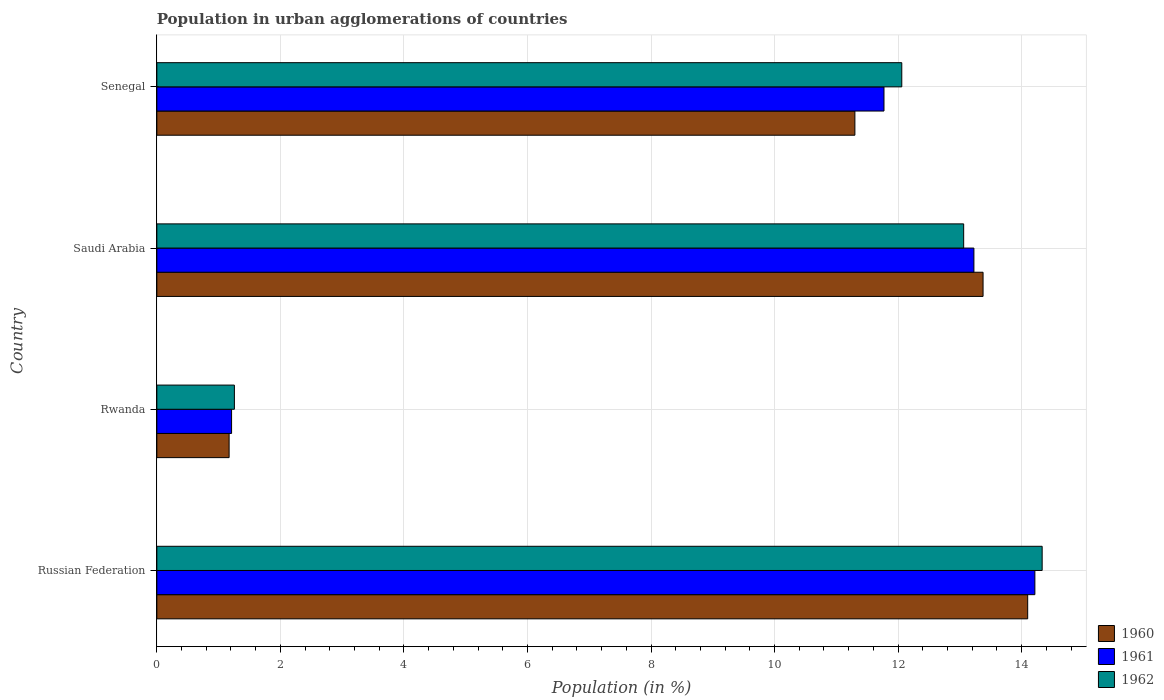How many bars are there on the 4th tick from the top?
Provide a succinct answer. 3. What is the label of the 2nd group of bars from the top?
Offer a very short reply. Saudi Arabia. What is the percentage of population in urban agglomerations in 1962 in Russian Federation?
Keep it short and to the point. 14.33. Across all countries, what is the maximum percentage of population in urban agglomerations in 1960?
Offer a very short reply. 14.1. Across all countries, what is the minimum percentage of population in urban agglomerations in 1962?
Offer a terse response. 1.26. In which country was the percentage of population in urban agglomerations in 1960 maximum?
Ensure brevity in your answer.  Russian Federation. In which country was the percentage of population in urban agglomerations in 1960 minimum?
Make the answer very short. Rwanda. What is the total percentage of population in urban agglomerations in 1962 in the graph?
Your answer should be very brief. 40.71. What is the difference between the percentage of population in urban agglomerations in 1962 in Saudi Arabia and that in Senegal?
Offer a terse response. 1. What is the difference between the percentage of population in urban agglomerations in 1961 in Rwanda and the percentage of population in urban agglomerations in 1960 in Senegal?
Your answer should be compact. -10.09. What is the average percentage of population in urban agglomerations in 1960 per country?
Provide a short and direct response. 9.99. What is the difference between the percentage of population in urban agglomerations in 1960 and percentage of population in urban agglomerations in 1962 in Rwanda?
Your answer should be very brief. -0.09. In how many countries, is the percentage of population in urban agglomerations in 1960 greater than 2.8 %?
Provide a succinct answer. 3. What is the ratio of the percentage of population in urban agglomerations in 1960 in Saudi Arabia to that in Senegal?
Your response must be concise. 1.18. Is the percentage of population in urban agglomerations in 1962 in Russian Federation less than that in Senegal?
Offer a terse response. No. What is the difference between the highest and the second highest percentage of population in urban agglomerations in 1961?
Offer a very short reply. 0.99. What is the difference between the highest and the lowest percentage of population in urban agglomerations in 1962?
Your answer should be compact. 13.08. In how many countries, is the percentage of population in urban agglomerations in 1961 greater than the average percentage of population in urban agglomerations in 1961 taken over all countries?
Your answer should be very brief. 3. What does the 1st bar from the top in Senegal represents?
Offer a very short reply. 1962. What does the 3rd bar from the bottom in Russian Federation represents?
Provide a short and direct response. 1962. Is it the case that in every country, the sum of the percentage of population in urban agglomerations in 1960 and percentage of population in urban agglomerations in 1961 is greater than the percentage of population in urban agglomerations in 1962?
Provide a short and direct response. Yes. How many bars are there?
Ensure brevity in your answer.  12. How many countries are there in the graph?
Give a very brief answer. 4. Are the values on the major ticks of X-axis written in scientific E-notation?
Offer a terse response. No. Does the graph contain any zero values?
Make the answer very short. No. Does the graph contain grids?
Make the answer very short. Yes. Where does the legend appear in the graph?
Make the answer very short. Bottom right. How many legend labels are there?
Keep it short and to the point. 3. What is the title of the graph?
Provide a short and direct response. Population in urban agglomerations of countries. Does "2013" appear as one of the legend labels in the graph?
Offer a terse response. No. What is the label or title of the Y-axis?
Your response must be concise. Country. What is the Population (in %) of 1960 in Russian Federation?
Your answer should be compact. 14.1. What is the Population (in %) of 1961 in Russian Federation?
Offer a very short reply. 14.21. What is the Population (in %) in 1962 in Russian Federation?
Your answer should be very brief. 14.33. What is the Population (in %) of 1960 in Rwanda?
Provide a short and direct response. 1.17. What is the Population (in %) in 1961 in Rwanda?
Provide a short and direct response. 1.21. What is the Population (in %) in 1962 in Rwanda?
Give a very brief answer. 1.26. What is the Population (in %) of 1960 in Saudi Arabia?
Keep it short and to the point. 13.38. What is the Population (in %) in 1961 in Saudi Arabia?
Ensure brevity in your answer.  13.23. What is the Population (in %) of 1962 in Saudi Arabia?
Provide a succinct answer. 13.06. What is the Population (in %) in 1960 in Senegal?
Your answer should be compact. 11.3. What is the Population (in %) of 1961 in Senegal?
Provide a succinct answer. 11.77. What is the Population (in %) of 1962 in Senegal?
Offer a very short reply. 12.06. Across all countries, what is the maximum Population (in %) in 1960?
Make the answer very short. 14.1. Across all countries, what is the maximum Population (in %) in 1961?
Offer a very short reply. 14.21. Across all countries, what is the maximum Population (in %) of 1962?
Provide a succinct answer. 14.33. Across all countries, what is the minimum Population (in %) in 1960?
Keep it short and to the point. 1.17. Across all countries, what is the minimum Population (in %) of 1961?
Make the answer very short. 1.21. Across all countries, what is the minimum Population (in %) in 1962?
Your answer should be compact. 1.26. What is the total Population (in %) of 1960 in the graph?
Provide a short and direct response. 39.95. What is the total Population (in %) in 1961 in the graph?
Give a very brief answer. 40.42. What is the total Population (in %) of 1962 in the graph?
Give a very brief answer. 40.71. What is the difference between the Population (in %) of 1960 in Russian Federation and that in Rwanda?
Keep it short and to the point. 12.93. What is the difference between the Population (in %) of 1961 in Russian Federation and that in Rwanda?
Offer a very short reply. 13. What is the difference between the Population (in %) of 1962 in Russian Federation and that in Rwanda?
Offer a very short reply. 13.08. What is the difference between the Population (in %) in 1960 in Russian Federation and that in Saudi Arabia?
Ensure brevity in your answer.  0.72. What is the difference between the Population (in %) in 1961 in Russian Federation and that in Saudi Arabia?
Give a very brief answer. 0.99. What is the difference between the Population (in %) of 1962 in Russian Federation and that in Saudi Arabia?
Give a very brief answer. 1.27. What is the difference between the Population (in %) of 1960 in Russian Federation and that in Senegal?
Provide a short and direct response. 2.8. What is the difference between the Population (in %) in 1961 in Russian Federation and that in Senegal?
Your response must be concise. 2.44. What is the difference between the Population (in %) in 1962 in Russian Federation and that in Senegal?
Your answer should be compact. 2.27. What is the difference between the Population (in %) of 1960 in Rwanda and that in Saudi Arabia?
Keep it short and to the point. -12.21. What is the difference between the Population (in %) of 1961 in Rwanda and that in Saudi Arabia?
Provide a short and direct response. -12.02. What is the difference between the Population (in %) in 1962 in Rwanda and that in Saudi Arabia?
Your answer should be very brief. -11.81. What is the difference between the Population (in %) in 1960 in Rwanda and that in Senegal?
Your response must be concise. -10.13. What is the difference between the Population (in %) in 1961 in Rwanda and that in Senegal?
Your response must be concise. -10.56. What is the difference between the Population (in %) of 1962 in Rwanda and that in Senegal?
Your answer should be very brief. -10.8. What is the difference between the Population (in %) of 1960 in Saudi Arabia and that in Senegal?
Offer a very short reply. 2.07. What is the difference between the Population (in %) in 1961 in Saudi Arabia and that in Senegal?
Offer a very short reply. 1.46. What is the difference between the Population (in %) of 1962 in Saudi Arabia and that in Senegal?
Offer a very short reply. 1. What is the difference between the Population (in %) in 1960 in Russian Federation and the Population (in %) in 1961 in Rwanda?
Your response must be concise. 12.89. What is the difference between the Population (in %) of 1960 in Russian Federation and the Population (in %) of 1962 in Rwanda?
Keep it short and to the point. 12.84. What is the difference between the Population (in %) of 1961 in Russian Federation and the Population (in %) of 1962 in Rwanda?
Your response must be concise. 12.96. What is the difference between the Population (in %) in 1960 in Russian Federation and the Population (in %) in 1961 in Saudi Arabia?
Offer a terse response. 0.87. What is the difference between the Population (in %) in 1960 in Russian Federation and the Population (in %) in 1962 in Saudi Arabia?
Keep it short and to the point. 1.04. What is the difference between the Population (in %) in 1961 in Russian Federation and the Population (in %) in 1962 in Saudi Arabia?
Ensure brevity in your answer.  1.15. What is the difference between the Population (in %) in 1960 in Russian Federation and the Population (in %) in 1961 in Senegal?
Offer a terse response. 2.33. What is the difference between the Population (in %) of 1960 in Russian Federation and the Population (in %) of 1962 in Senegal?
Offer a very short reply. 2.04. What is the difference between the Population (in %) in 1961 in Russian Federation and the Population (in %) in 1962 in Senegal?
Offer a very short reply. 2.15. What is the difference between the Population (in %) in 1960 in Rwanda and the Population (in %) in 1961 in Saudi Arabia?
Give a very brief answer. -12.06. What is the difference between the Population (in %) in 1960 in Rwanda and the Population (in %) in 1962 in Saudi Arabia?
Ensure brevity in your answer.  -11.89. What is the difference between the Population (in %) in 1961 in Rwanda and the Population (in %) in 1962 in Saudi Arabia?
Your answer should be compact. -11.85. What is the difference between the Population (in %) of 1960 in Rwanda and the Population (in %) of 1961 in Senegal?
Your answer should be compact. -10.6. What is the difference between the Population (in %) of 1960 in Rwanda and the Population (in %) of 1962 in Senegal?
Provide a short and direct response. -10.89. What is the difference between the Population (in %) in 1961 in Rwanda and the Population (in %) in 1962 in Senegal?
Make the answer very short. -10.85. What is the difference between the Population (in %) in 1960 in Saudi Arabia and the Population (in %) in 1961 in Senegal?
Ensure brevity in your answer.  1.6. What is the difference between the Population (in %) of 1960 in Saudi Arabia and the Population (in %) of 1962 in Senegal?
Keep it short and to the point. 1.32. What is the difference between the Population (in %) in 1961 in Saudi Arabia and the Population (in %) in 1962 in Senegal?
Keep it short and to the point. 1.17. What is the average Population (in %) of 1960 per country?
Provide a succinct answer. 9.99. What is the average Population (in %) of 1961 per country?
Your response must be concise. 10.11. What is the average Population (in %) of 1962 per country?
Your answer should be very brief. 10.18. What is the difference between the Population (in %) of 1960 and Population (in %) of 1961 in Russian Federation?
Make the answer very short. -0.12. What is the difference between the Population (in %) in 1960 and Population (in %) in 1962 in Russian Federation?
Offer a terse response. -0.23. What is the difference between the Population (in %) of 1961 and Population (in %) of 1962 in Russian Federation?
Offer a very short reply. -0.12. What is the difference between the Population (in %) in 1960 and Population (in %) in 1961 in Rwanda?
Ensure brevity in your answer.  -0.04. What is the difference between the Population (in %) in 1960 and Population (in %) in 1962 in Rwanda?
Provide a succinct answer. -0.09. What is the difference between the Population (in %) in 1961 and Population (in %) in 1962 in Rwanda?
Provide a succinct answer. -0.05. What is the difference between the Population (in %) in 1960 and Population (in %) in 1961 in Saudi Arabia?
Provide a short and direct response. 0.15. What is the difference between the Population (in %) of 1960 and Population (in %) of 1962 in Saudi Arabia?
Your answer should be compact. 0.31. What is the difference between the Population (in %) in 1961 and Population (in %) in 1962 in Saudi Arabia?
Make the answer very short. 0.17. What is the difference between the Population (in %) of 1960 and Population (in %) of 1961 in Senegal?
Give a very brief answer. -0.47. What is the difference between the Population (in %) in 1960 and Population (in %) in 1962 in Senegal?
Provide a short and direct response. -0.76. What is the difference between the Population (in %) in 1961 and Population (in %) in 1962 in Senegal?
Keep it short and to the point. -0.29. What is the ratio of the Population (in %) in 1960 in Russian Federation to that in Rwanda?
Provide a short and direct response. 12.05. What is the ratio of the Population (in %) of 1961 in Russian Federation to that in Rwanda?
Offer a very short reply. 11.75. What is the ratio of the Population (in %) of 1962 in Russian Federation to that in Rwanda?
Provide a succinct answer. 11.42. What is the ratio of the Population (in %) in 1960 in Russian Federation to that in Saudi Arabia?
Your answer should be very brief. 1.05. What is the ratio of the Population (in %) in 1961 in Russian Federation to that in Saudi Arabia?
Your answer should be compact. 1.07. What is the ratio of the Population (in %) in 1962 in Russian Federation to that in Saudi Arabia?
Provide a short and direct response. 1.1. What is the ratio of the Population (in %) in 1960 in Russian Federation to that in Senegal?
Keep it short and to the point. 1.25. What is the ratio of the Population (in %) in 1961 in Russian Federation to that in Senegal?
Make the answer very short. 1.21. What is the ratio of the Population (in %) of 1962 in Russian Federation to that in Senegal?
Provide a succinct answer. 1.19. What is the ratio of the Population (in %) in 1960 in Rwanda to that in Saudi Arabia?
Your answer should be very brief. 0.09. What is the ratio of the Population (in %) in 1961 in Rwanda to that in Saudi Arabia?
Your response must be concise. 0.09. What is the ratio of the Population (in %) of 1962 in Rwanda to that in Saudi Arabia?
Provide a succinct answer. 0.1. What is the ratio of the Population (in %) in 1960 in Rwanda to that in Senegal?
Ensure brevity in your answer.  0.1. What is the ratio of the Population (in %) of 1961 in Rwanda to that in Senegal?
Your answer should be very brief. 0.1. What is the ratio of the Population (in %) in 1962 in Rwanda to that in Senegal?
Keep it short and to the point. 0.1. What is the ratio of the Population (in %) in 1960 in Saudi Arabia to that in Senegal?
Ensure brevity in your answer.  1.18. What is the ratio of the Population (in %) in 1961 in Saudi Arabia to that in Senegal?
Your answer should be compact. 1.12. What is the ratio of the Population (in %) in 1962 in Saudi Arabia to that in Senegal?
Offer a terse response. 1.08. What is the difference between the highest and the second highest Population (in %) in 1960?
Your answer should be very brief. 0.72. What is the difference between the highest and the second highest Population (in %) of 1961?
Offer a terse response. 0.99. What is the difference between the highest and the second highest Population (in %) in 1962?
Keep it short and to the point. 1.27. What is the difference between the highest and the lowest Population (in %) of 1960?
Keep it short and to the point. 12.93. What is the difference between the highest and the lowest Population (in %) in 1961?
Give a very brief answer. 13. What is the difference between the highest and the lowest Population (in %) in 1962?
Keep it short and to the point. 13.08. 